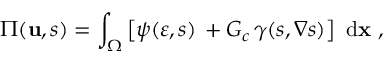<formula> <loc_0><loc_0><loc_500><loc_500>\Pi ( u , s ) = \int _ { \Omega } \left [ \psi ( \boldsymbol \varepsilon , s ) \, + G _ { c } \, \gamma ( s , \nabla s ) \right ] \ d x \ ,</formula> 